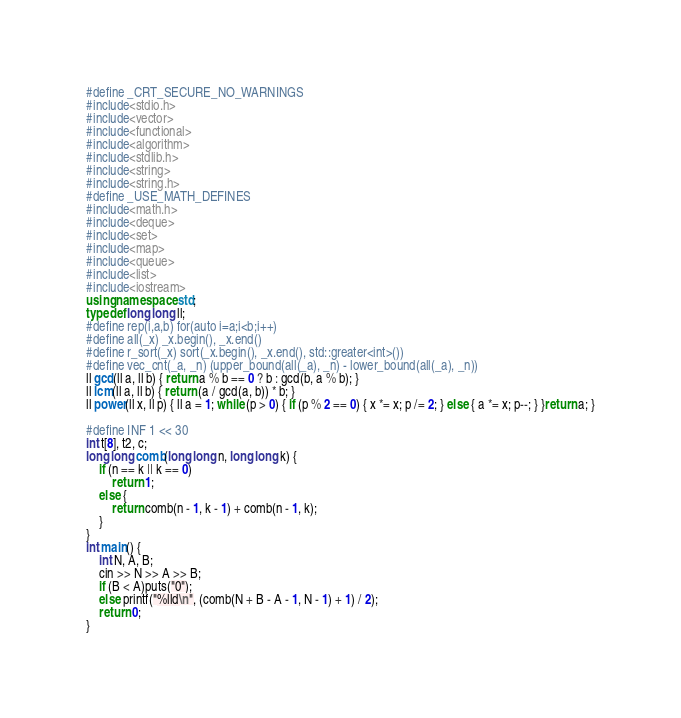<code> <loc_0><loc_0><loc_500><loc_500><_C++_>#define _CRT_SECURE_NO_WARNINGS
#include<stdio.h>
#include<vector>
#include<functional>
#include<algorithm>
#include<stdlib.h>
#include<string>
#include<string.h>
#define _USE_MATH_DEFINES
#include<math.h>
#include<deque>
#include<set>
#include<map>
#include<queue>
#include<list>
#include<iostream>
using namespace std;
typedef long long ll;
#define rep(i,a,b) for(auto i=a;i<b;i++)
#define all(_x) _x.begin(), _x.end()
#define r_sort(_x) sort(_x.begin(), _x.end(), std::greater<int>())
#define vec_cnt(_a, _n) (upper_bound(all(_a), _n) - lower_bound(all(_a), _n))
ll gcd(ll a, ll b) { return a % b == 0 ? b : gcd(b, a % b); }
ll lcm(ll a, ll b) { return (a / gcd(a, b)) * b; }
ll power(ll x, ll p) { ll a = 1; while (p > 0) { if (p % 2 == 0) { x *= x; p /= 2; } else { a *= x; p--; } }return a; }

#define INF 1 << 30
int t[8], t2, c;
long long comb(long long n, long long k) {
	if (n == k || k == 0)
		return 1;
	else {
		return comb(n - 1, k - 1) + comb(n - 1, k);
	}
}
int main() {
	int N, A, B;
	cin >> N >> A >> B;
	if (B < A)puts("0");
	else printf("%lld\n", (comb(N + B - A - 1, N - 1) + 1) / 2);
	return 0;
}
</code> 